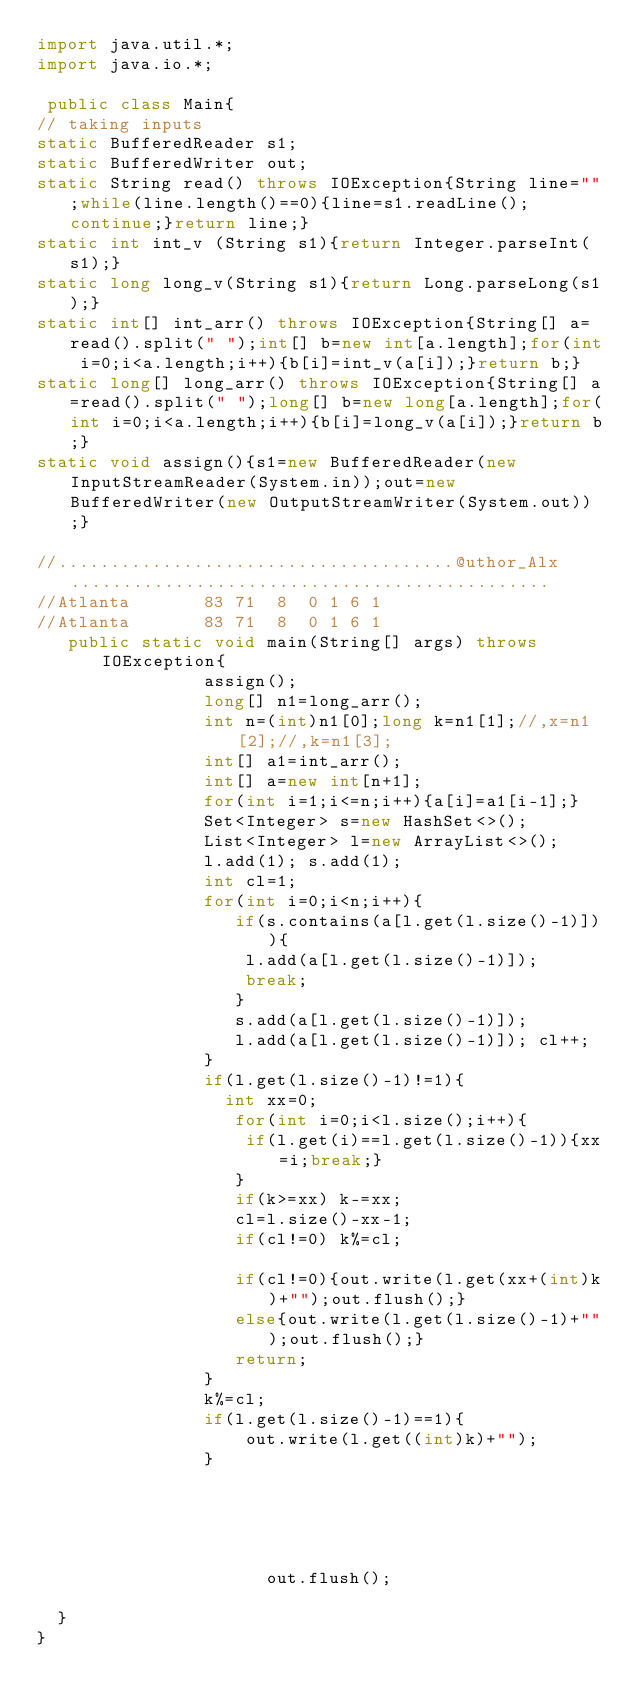Convert code to text. <code><loc_0><loc_0><loc_500><loc_500><_Java_>import java.util.*;
import java.io.*;

 public class Main{
// taking inputs
static BufferedReader s1;
static BufferedWriter out;
static String read() throws IOException{String line="";while(line.length()==0){line=s1.readLine();continue;}return line;}
static int int_v (String s1){return Integer.parseInt(s1);}
static long long_v(String s1){return Long.parseLong(s1);}
static int[] int_arr() throws IOException{String[] a=read().split(" ");int[] b=new int[a.length];for(int i=0;i<a.length;i++){b[i]=int_v(a[i]);}return b;}
static long[] long_arr() throws IOException{String[] a=read().split(" ");long[] b=new long[a.length];for(int i=0;i<a.length;i++){b[i]=long_v(a[i]);}return b;}
static void assign(){s1=new BufferedReader(new InputStreamReader(System.in));out=new BufferedWriter(new OutputStreamWriter(System.out));}

//......................................@uthor_Alx..............................................
//Atlanta       83 71  8  0 1 6 1
//Atlanta       83 71  8  0 1 6 1
   public static void main(String[] args) throws  IOException{
	        		  assign();
	        		  long[] n1=long_arr();
	        		  int n=(int)n1[0];long k=n1[1];//,x=n1[2];//,k=n1[3];
	        		  int[] a1=int_arr();
	        		  int[] a=new int[n+1];
	        		  for(int i=1;i<=n;i++){a[i]=a1[i-1];}
	        		  Set<Integer> s=new HashSet<>();
	        		  List<Integer> l=new ArrayList<>();
	        		  l.add(1); s.add(1);
	        		  int cl=1;
	        		  for(int i=0;i<n;i++){
	        		  	 if(s.contains(a[l.get(l.size()-1)])){
	        		  	 	l.add(a[l.get(l.size()-1)]);
	        		  	 	break;
	        		  	 }
	        		  	 s.add(a[l.get(l.size()-1)]);
	        		  	 l.add(a[l.get(l.size()-1)]); cl++;
	        		  }
	        		  if(l.get(l.size()-1)!=1){
	        		  	int xx=0;
	        		  	 for(int i=0;i<l.size();i++){
	        		  	 	if(l.get(i)==l.get(l.size()-1)){xx=i;break;}
	        		  	 }
	        		  	 if(k>=xx) k-=xx;
	        		  	 cl=l.size()-xx-1;
	        		  	 if(cl!=0) k%=cl;

	        		  	 if(cl!=0){out.write(l.get(xx+(int)k)+"");out.flush();}
	        		  	 else{out.write(l.get(l.size()-1)+"");out.flush();}
	        		  	 return;
	        		  }
	        		  k%=cl;
	        		  if(l.get(l.size()-1)==1){
	        		  	  out.write(l.get((int)k)+"");
	        		  }
	        		  
	        		  
	        		  
	        		  
	        	
                      out.flush();
	        		 
	}
}
	       
	          



	
  



</code> 